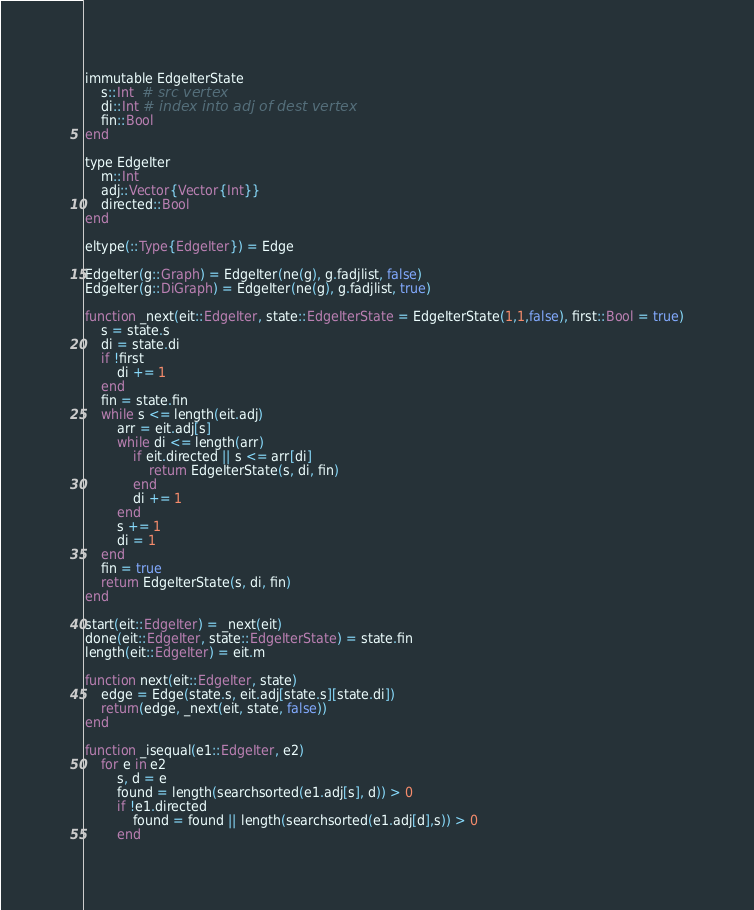<code> <loc_0><loc_0><loc_500><loc_500><_Julia_>immutable EdgeIterState
    s::Int  # src vertex
    di::Int # index into adj of dest vertex
    fin::Bool
end

type EdgeIter
    m::Int
    adj::Vector{Vector{Int}}
    directed::Bool
end

eltype(::Type{EdgeIter}) = Edge

EdgeIter(g::Graph) = EdgeIter(ne(g), g.fadjlist, false)
EdgeIter(g::DiGraph) = EdgeIter(ne(g), g.fadjlist, true)

function _next(eit::EdgeIter, state::EdgeIterState = EdgeIterState(1,1,false), first::Bool = true)
    s = state.s
    di = state.di
    if !first
        di += 1
    end
    fin = state.fin
    while s <= length(eit.adj)
        arr = eit.adj[s]
        while di <= length(arr)
            if eit.directed || s <= arr[di]
                return EdgeIterState(s, di, fin)
            end
            di += 1
        end
        s += 1
        di = 1
    end
    fin = true
    return EdgeIterState(s, di, fin)
end

start(eit::EdgeIter) = _next(eit)
done(eit::EdgeIter, state::EdgeIterState) = state.fin
length(eit::EdgeIter) = eit.m

function next(eit::EdgeIter, state)
    edge = Edge(state.s, eit.adj[state.s][state.di])
    return(edge, _next(eit, state, false))
end

function _isequal(e1::EdgeIter, e2)
    for e in e2
        s, d = e
        found = length(searchsorted(e1.adj[s], d)) > 0
        if !e1.directed
            found = found || length(searchsorted(e1.adj[d],s)) > 0
        end</code> 